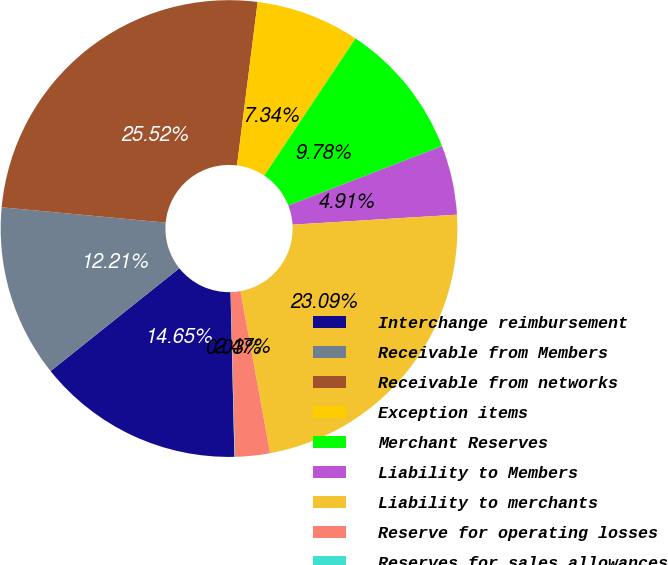Convert chart. <chart><loc_0><loc_0><loc_500><loc_500><pie_chart><fcel>Interchange reimbursement<fcel>Receivable from Members<fcel>Receivable from networks<fcel>Exception items<fcel>Merchant Reserves<fcel>Liability to Members<fcel>Liability to merchants<fcel>Reserve for operating losses<fcel>Reserves for sales allowances<nl><fcel>14.65%<fcel>12.21%<fcel>25.52%<fcel>7.34%<fcel>9.78%<fcel>4.91%<fcel>23.09%<fcel>2.47%<fcel>0.03%<nl></chart> 